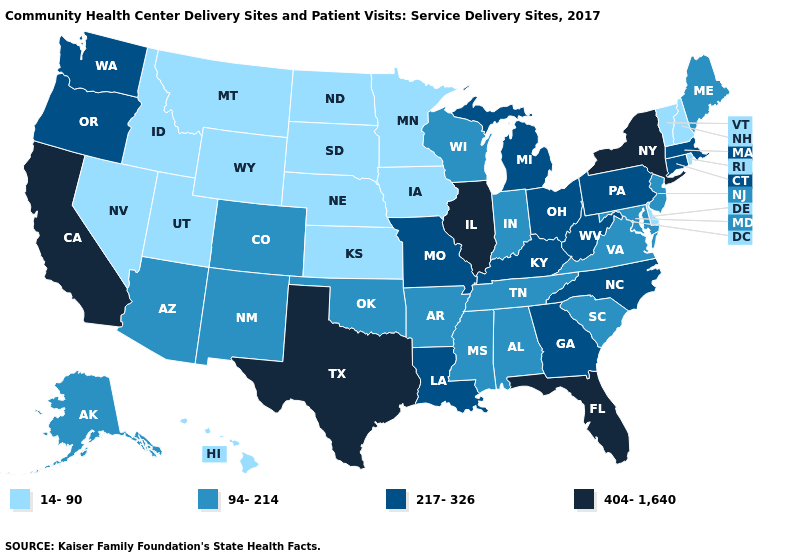Name the states that have a value in the range 217-326?
Short answer required. Connecticut, Georgia, Kentucky, Louisiana, Massachusetts, Michigan, Missouri, North Carolina, Ohio, Oregon, Pennsylvania, Washington, West Virginia. What is the highest value in the South ?
Short answer required. 404-1,640. What is the lowest value in states that border New Jersey?
Write a very short answer. 14-90. What is the value of Indiana?
Keep it brief. 94-214. Does Virginia have a higher value than Washington?
Keep it brief. No. Name the states that have a value in the range 94-214?
Answer briefly. Alabama, Alaska, Arizona, Arkansas, Colorado, Indiana, Maine, Maryland, Mississippi, New Jersey, New Mexico, Oklahoma, South Carolina, Tennessee, Virginia, Wisconsin. Does Oregon have a lower value than Florida?
Quick response, please. Yes. Does the map have missing data?
Short answer required. No. Which states have the lowest value in the Northeast?
Give a very brief answer. New Hampshire, Rhode Island, Vermont. Among the states that border Wisconsin , which have the highest value?
Answer briefly. Illinois. What is the lowest value in states that border Missouri?
Keep it brief. 14-90. Among the states that border Louisiana , does Mississippi have the lowest value?
Answer briefly. Yes. What is the value of New Hampshire?
Be succinct. 14-90. Name the states that have a value in the range 217-326?
Keep it brief. Connecticut, Georgia, Kentucky, Louisiana, Massachusetts, Michigan, Missouri, North Carolina, Ohio, Oregon, Pennsylvania, Washington, West Virginia. Is the legend a continuous bar?
Keep it brief. No. 